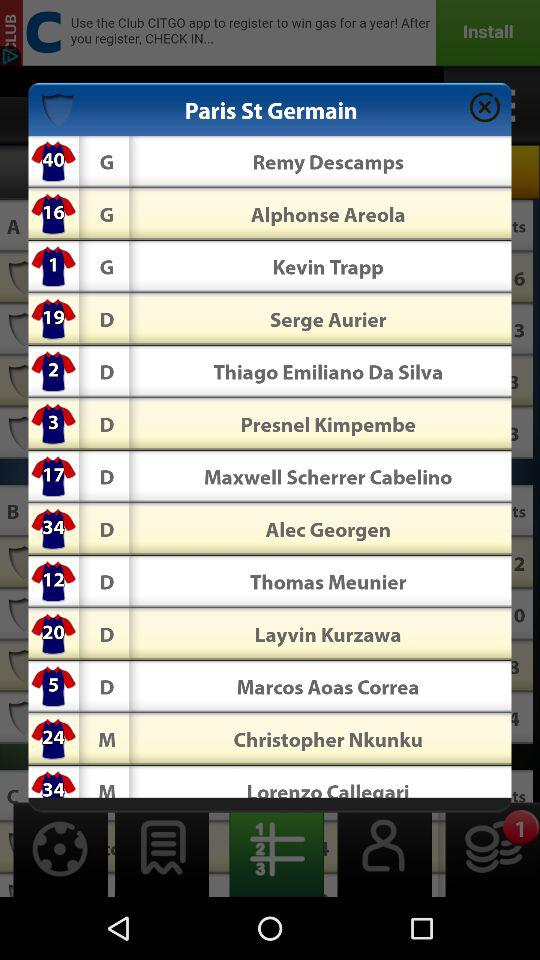What is the position of Remy Descamps? Remy Descamps' position is goalkeeper. 